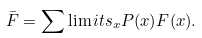Convert formula to latex. <formula><loc_0><loc_0><loc_500><loc_500>\bar { F } = \sum \lim i t s _ { x } P ( x ) F ( x ) .</formula> 